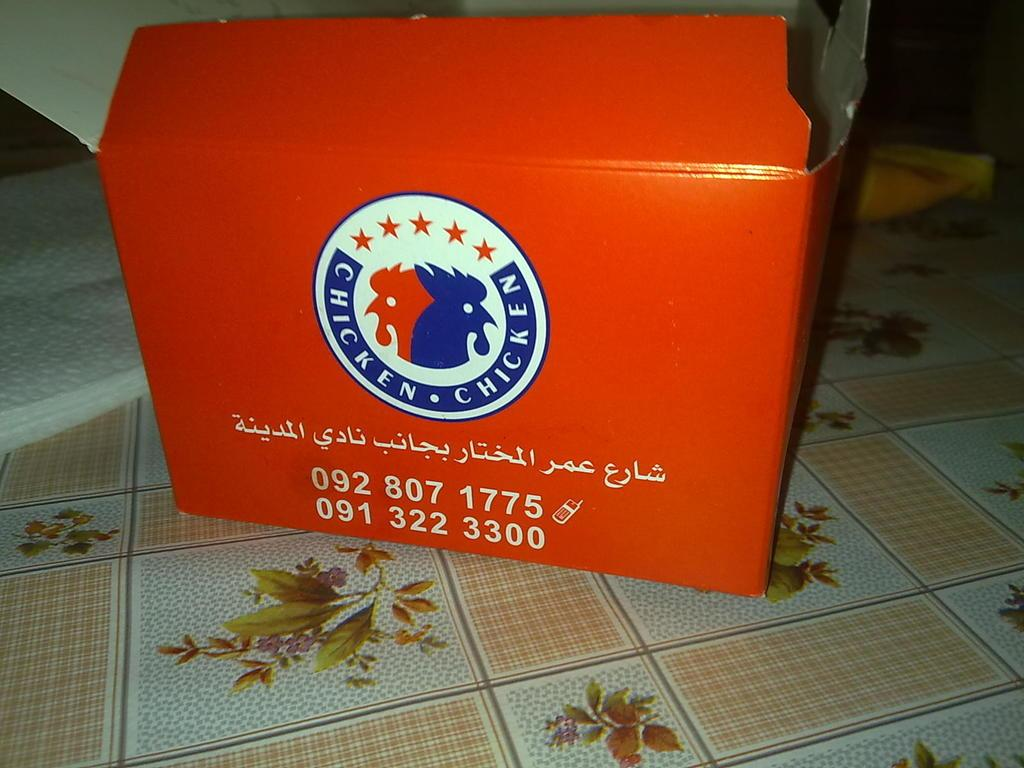<image>
Give a short and clear explanation of the subsequent image. Red box with a round label with stars and Chicken chicken imprinted on it. 